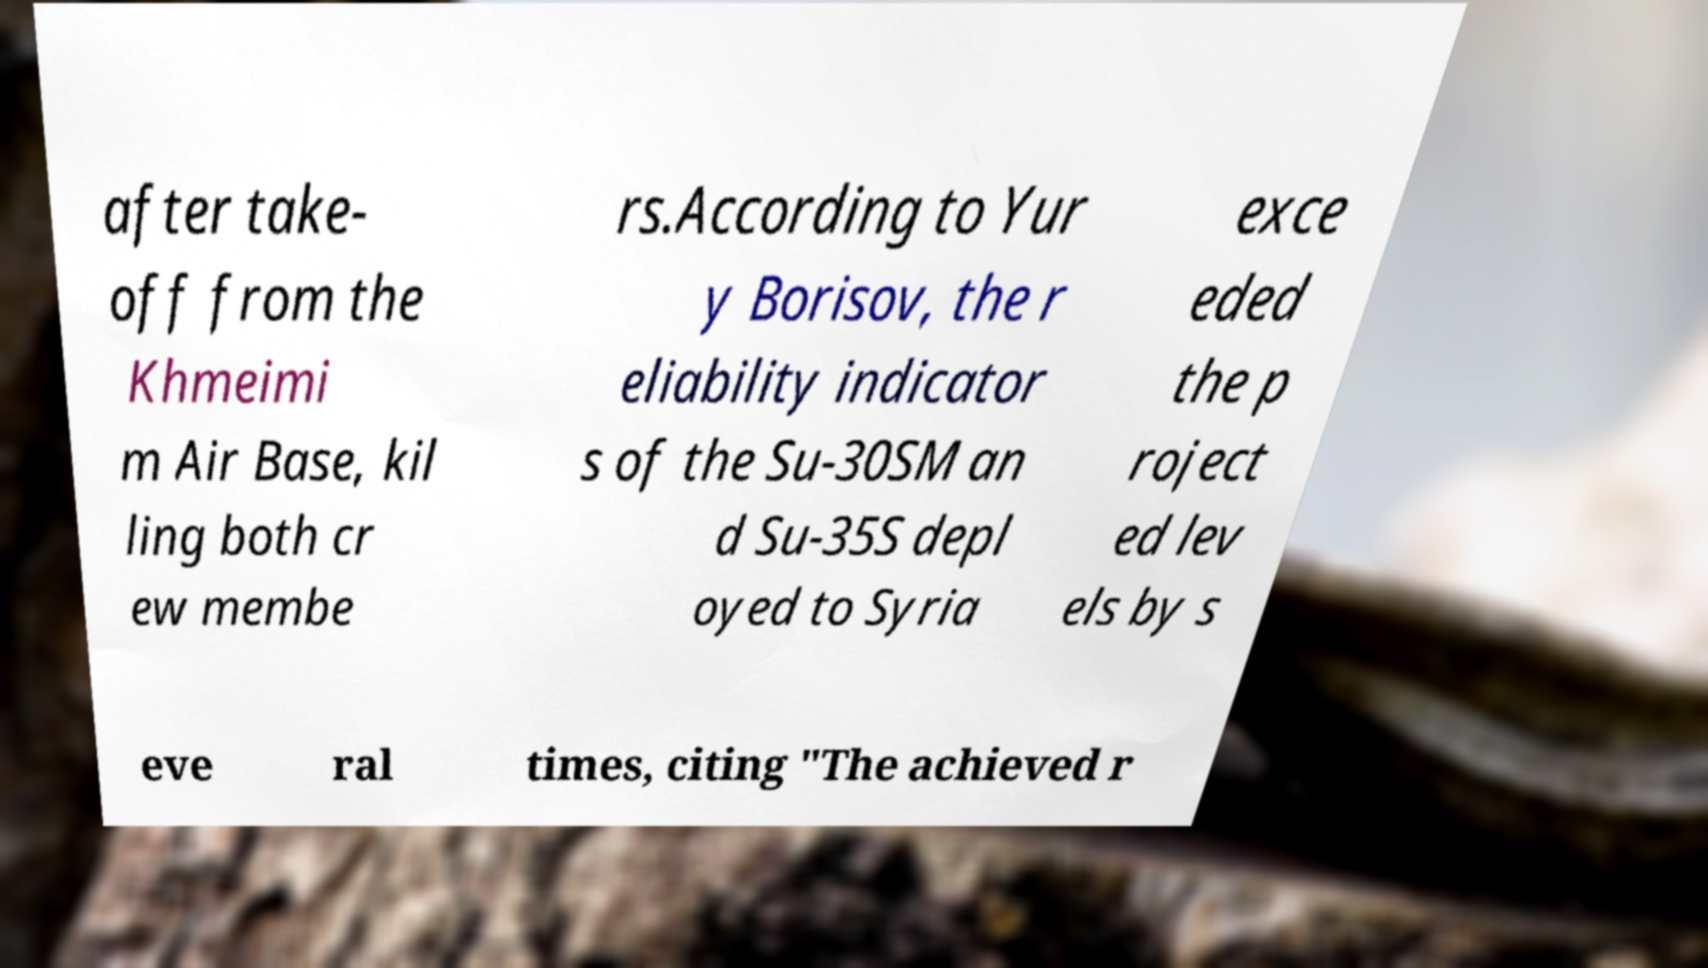For documentation purposes, I need the text within this image transcribed. Could you provide that? after take- off from the Khmeimi m Air Base, kil ling both cr ew membe rs.According to Yur y Borisov, the r eliability indicator s of the Su-30SM an d Su-35S depl oyed to Syria exce eded the p roject ed lev els by s eve ral times, citing "The achieved r 